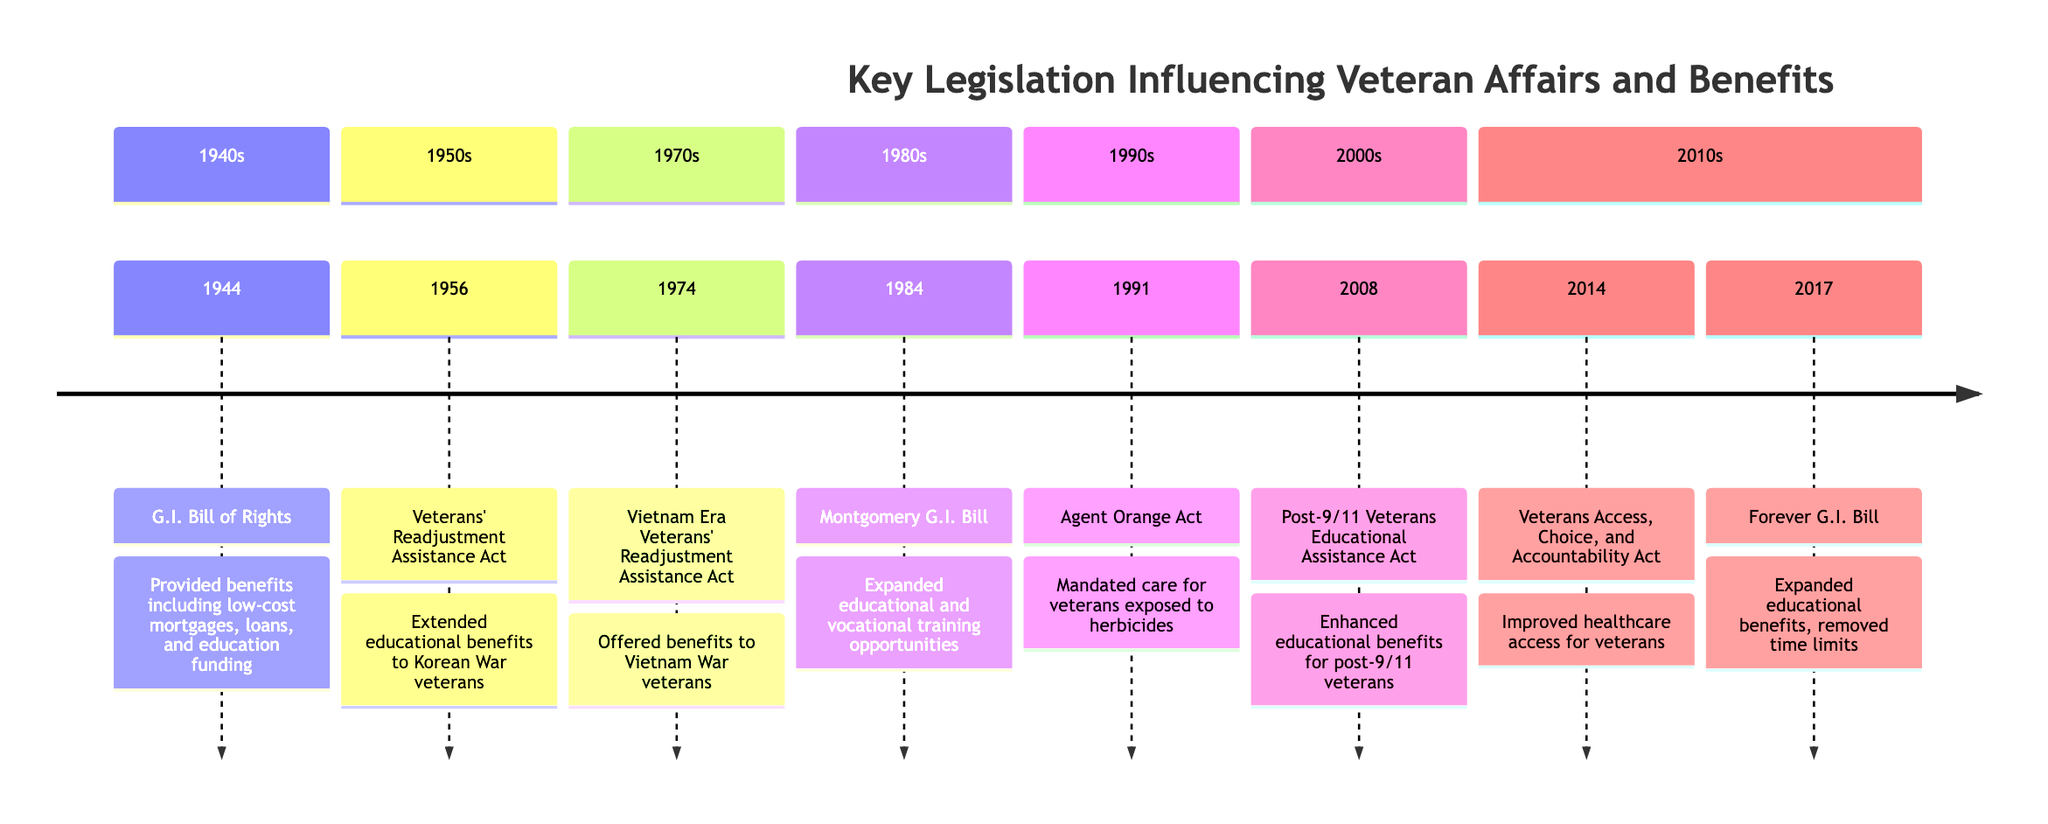What year was the G.I. Bill of Rights enacted? The timeline shows that the G.I. Bill of Rights was enacted in the year 1944.
Answer: 1944 Which act extended educational benefits to Korean War veterans? Referring to the entry in the timeline for 1956, it states that the Veterans' Readjustment Assistance Act extended educational benefits to Korean War veterans.
Answer: Veterans' Readjustment Assistance Act How many key legislations are listed in the timeline? By counting the entries in the timeline, there are a total of 8 key legislations listed.
Answer: 8 What type of benefits did the Agent Orange Act mandate for affected veterans? The entry for the Agent Orange Act in the timeline specifies that it mandated medical care and disability compensation for veterans exposed to Agent Orange.
Answer: Medical care and disability compensation What was the primary focus of the Veterans Access, Choice, and Accountability Act? The timeline highlights that this act primarily focused on improving healthcare access for veterans, including provisions for private sector care.
Answer: Improving healthcare access Which act removed the time limit on educational benefits? By reviewing the information for 2017, the Forever G.I. Bill is noted for expanding educational benefits by removing the time limit on these benefits.
Answer: Forever G.I. Bill In which decade was the Montgomery G.I. Bill passed? The timeline indicates that the Montgomery G.I. Bill was passed in 1984, which falls into the 1980s decade.
Answer: 1980s What is the full name of the act known as the Post-9/11 G.I. Bill? The timeline identifies the Post-9/11 Veterans Educational Assistance Act as the full title of this legislation.
Answer: Post-9/11 Veterans Educational Assistance Act Which legislation was designed specifically for Vietnam War veterans? The entry for 1974 in the timeline clearly states that the Vietnam Era Veterans' Readjustment Assistance Act was designed specifically for Vietnam War veterans.
Answer: Vietnam Era Veterans' Readjustment Assistance Act 